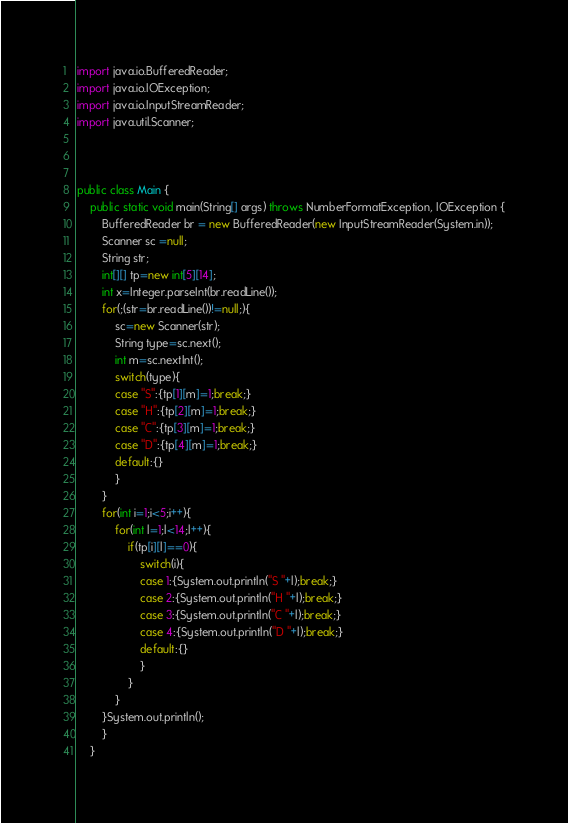<code> <loc_0><loc_0><loc_500><loc_500><_Java_>import java.io.BufferedReader;
import java.io.IOException;
import java.io.InputStreamReader;
import java.util.Scanner;



public class Main {
	public static void main(String[] args) throws NumberFormatException, IOException {
		BufferedReader br = new BufferedReader(new InputStreamReader(System.in));
		Scanner sc =null;
		String str;
		int[][] tp=new int[5][14];
		int x=Integer.parseInt(br.readLine());
		for(;(str=br.readLine())!=null;){
			sc=new Scanner(str);
			String type=sc.next();
			int m=sc.nextInt();
			switch(type){
			case "S":{tp[1][m]=1;break;}
			case "H":{tp[2][m]=1;break;}
			case "C":{tp[3][m]=1;break;}
			case "D":{tp[4][m]=1;break;}
			default:{}
			}
		}
		for(int i=1;i<5;i++){
			for(int l=1;l<14;l++){
				if(tp[i][l]==0){
					switch(i){
					case 1:{System.out.println("S "+l);break;}
					case 2:{System.out.println("H "+l);break;}
					case 3:{System.out.println("C "+l);break;}
					case 4:{System.out.println("D "+l);break;}
					default:{}
					}
				}
			}
		}System.out.println();
		}		
	}</code> 